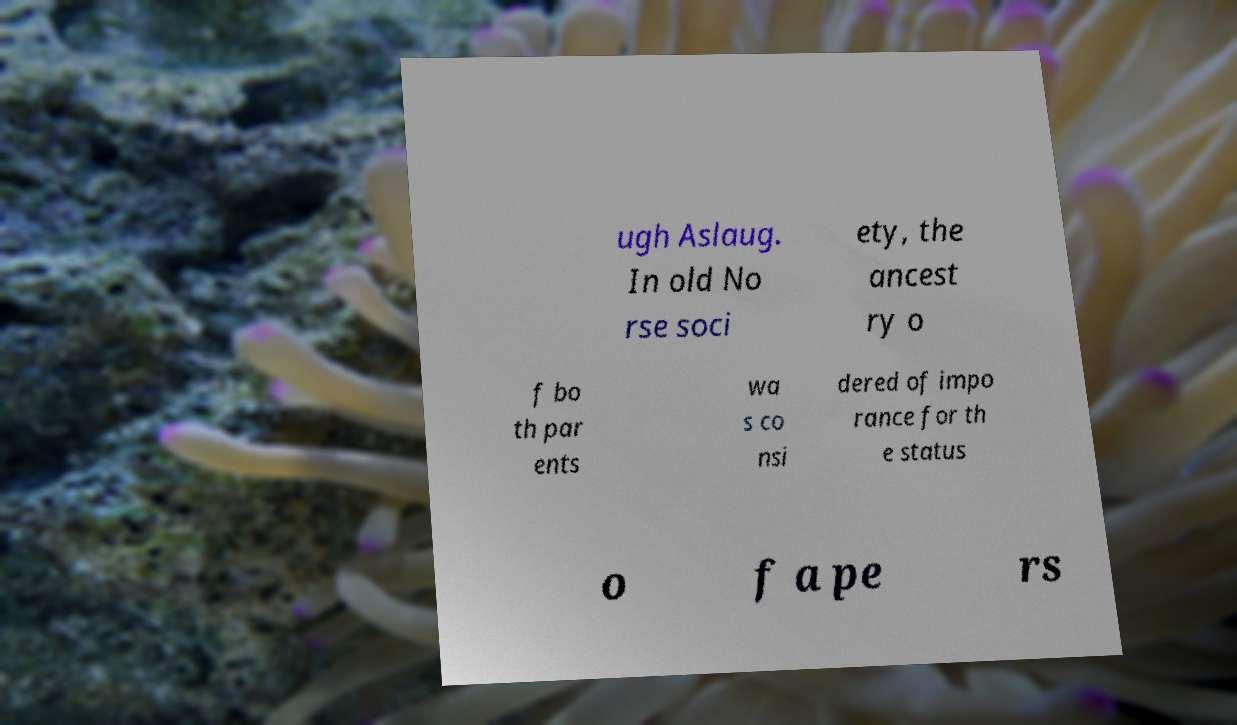Could you extract and type out the text from this image? ugh Aslaug. In old No rse soci ety, the ancest ry o f bo th par ents wa s co nsi dered of impo rance for th e status o f a pe rs 